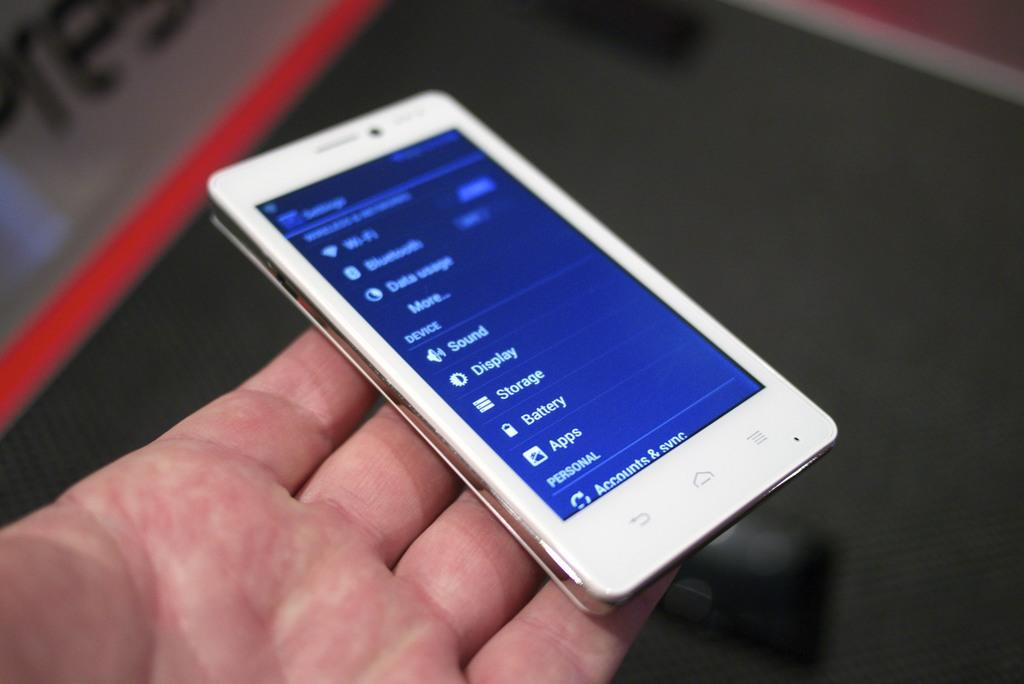<image>
Describe the image concisely. A phone is being held with the screen displaying settings such as sound, display, storeage, battery, and apps. 